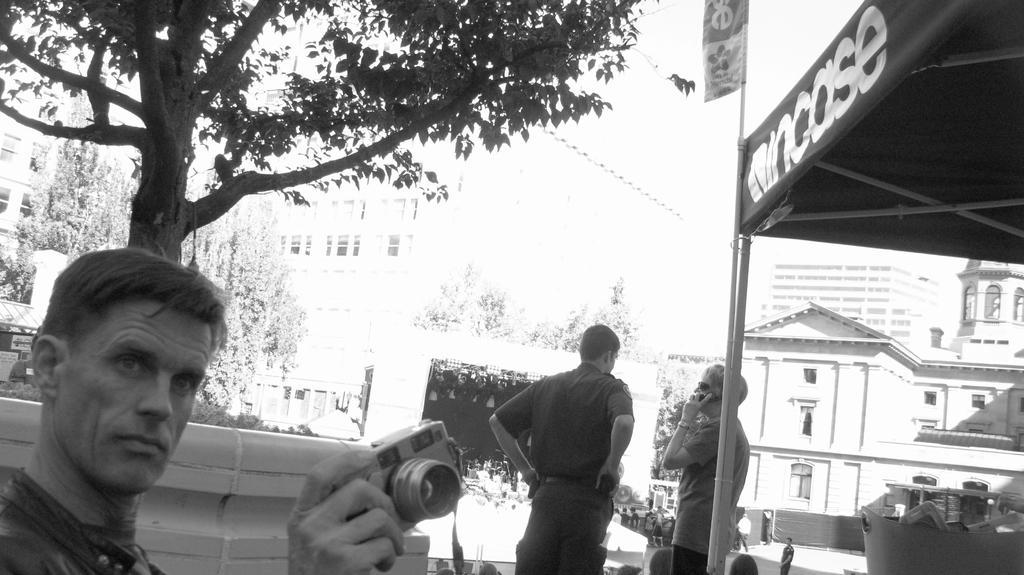How would you summarize this image in a sentence or two? In the image a man with camera in his hand on left side corner and behind him there is a tree. To the right side there are two men of which one is talking on phone and on the right side background there are buildings and beside building there are trees. 